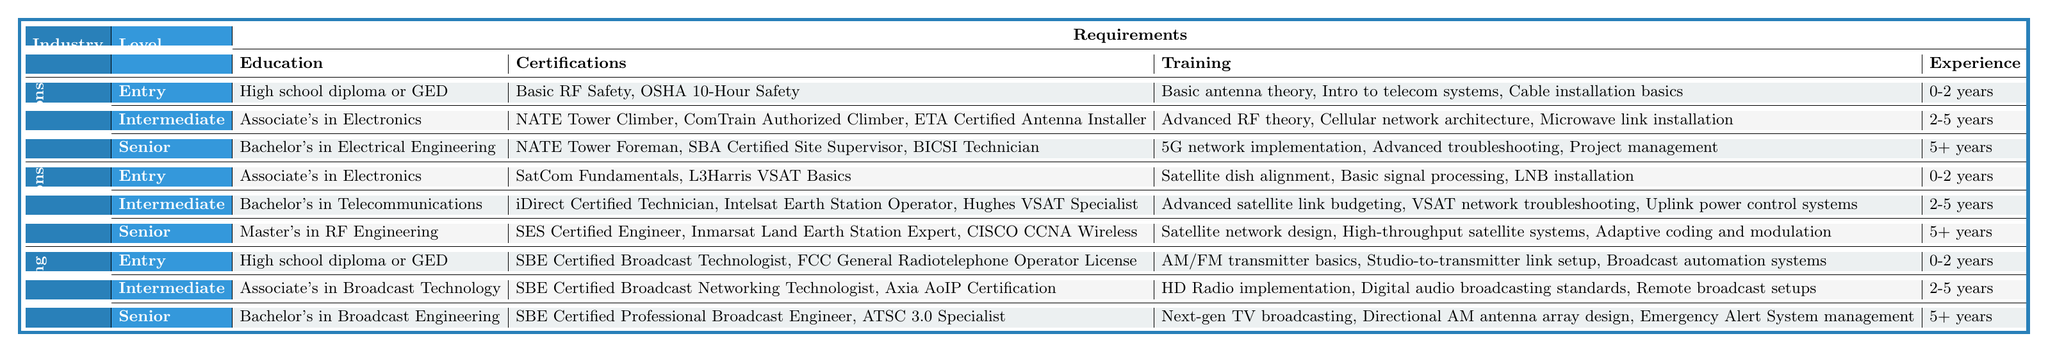What is the education requirement for an Intermediate Level technician in the Telecommunications Industry? According to the table, an Intermediate Level technician in the Telecommunications Industry must have an Associate's degree in Electronics or a related field.
Answer: Associate's degree in Electronics or related field How many certifications does a Senior Level technician in Satellite Communications need? The table lists three certifications required for Senior Level technicians in Satellite Communications: SES Certified Engineer, Inmarsat Land Earth Station Expert, and CISCO CCNA Wireless.
Answer: Three certifications Is a high school diploma necessary for Entry Level technicians in Broadcasting? Yes, the table states that the education requirement for Entry Level technicians in Broadcasting is a high school diploma or GED.
Answer: Yes What is the range of experience required for an Intermediate Level technician in Broadcasting? The table indicates that Intermediate Level technicians in Broadcasting need 2-5 years of experience.
Answer: 2-5 years Which industry has the highest educational requirement for Senior Level technicians? The table shows that the Satellite Communications industry requires a Master's degree in RF Engineering for Senior Level technicians, which is higher than the Bachelor’s degree required in Telecommunications and Broadcasting.
Answer: Satellite Communications How many training topics are covered for Entry Level technicians in Telecommunications and Entry Level technicians in Satellite Communications combined? Entry Level technicians in Telecommunications have three training topics, and Entry Level technicians in Satellite Communications also have three training topics. Combining these gives a total of 3 + 3 = 6 training topics.
Answer: 6 training topics Which certifications are required for Intermediate Level Satellite Communications technicians? The certifications required for Intermediate Level technicians in Satellite Communications are: iDirect Certified Technician, Intelsat Earth Station Operator, and Hughes VSAT Specialist, totaling three certifications.
Answer: Three certifications Does an Entry Level technician in Telecommunications require prior experience? No, the table indicates that Entry Level technicians in Telecommunications do not require prior experience, with the experience listed as 0-2 years.
Answer: No What type of degree is required for Senior Level technicians in the Broadcasting industry? The table specifies that a Bachelor's degree in Broadcast Engineering is required for Senior Level technicians in Broadcasting.
Answer: Bachelor's degree in Broadcast Engineering What are the two main training areas for Intermediate Level technicians in the Satellite Communications industry? The training areas for Intermediate Level technicians in Satellite Communications include Advanced satellite link budgeting and VSAT network troubleshooting, along with Uplink power control systems.
Answer: Advanced satellite link budgeting and VSAT network troubleshooting 